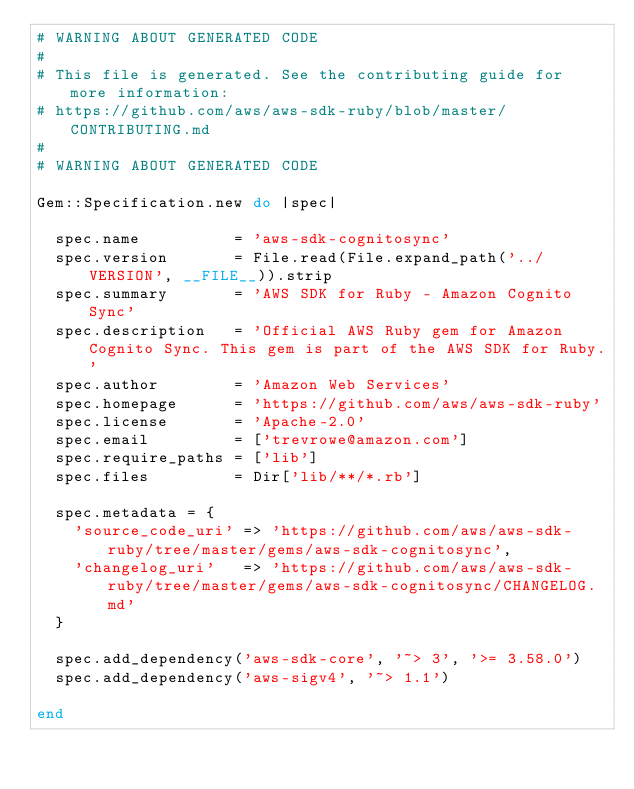<code> <loc_0><loc_0><loc_500><loc_500><_Ruby_># WARNING ABOUT GENERATED CODE
#
# This file is generated. See the contributing guide for more information:
# https://github.com/aws/aws-sdk-ruby/blob/master/CONTRIBUTING.md
#
# WARNING ABOUT GENERATED CODE

Gem::Specification.new do |spec|

  spec.name          = 'aws-sdk-cognitosync'
  spec.version       = File.read(File.expand_path('../VERSION', __FILE__)).strip
  spec.summary       = 'AWS SDK for Ruby - Amazon Cognito Sync'
  spec.description   = 'Official AWS Ruby gem for Amazon Cognito Sync. This gem is part of the AWS SDK for Ruby.'
  spec.author        = 'Amazon Web Services'
  spec.homepage      = 'https://github.com/aws/aws-sdk-ruby'
  spec.license       = 'Apache-2.0'
  spec.email         = ['trevrowe@amazon.com']
  spec.require_paths = ['lib']
  spec.files         = Dir['lib/**/*.rb']

  spec.metadata = {
    'source_code_uri' => 'https://github.com/aws/aws-sdk-ruby/tree/master/gems/aws-sdk-cognitosync',
    'changelog_uri'   => 'https://github.com/aws/aws-sdk-ruby/tree/master/gems/aws-sdk-cognitosync/CHANGELOG.md'
  }

  spec.add_dependency('aws-sdk-core', '~> 3', '>= 3.58.0')
  spec.add_dependency('aws-sigv4', '~> 1.1')

end
</code> 